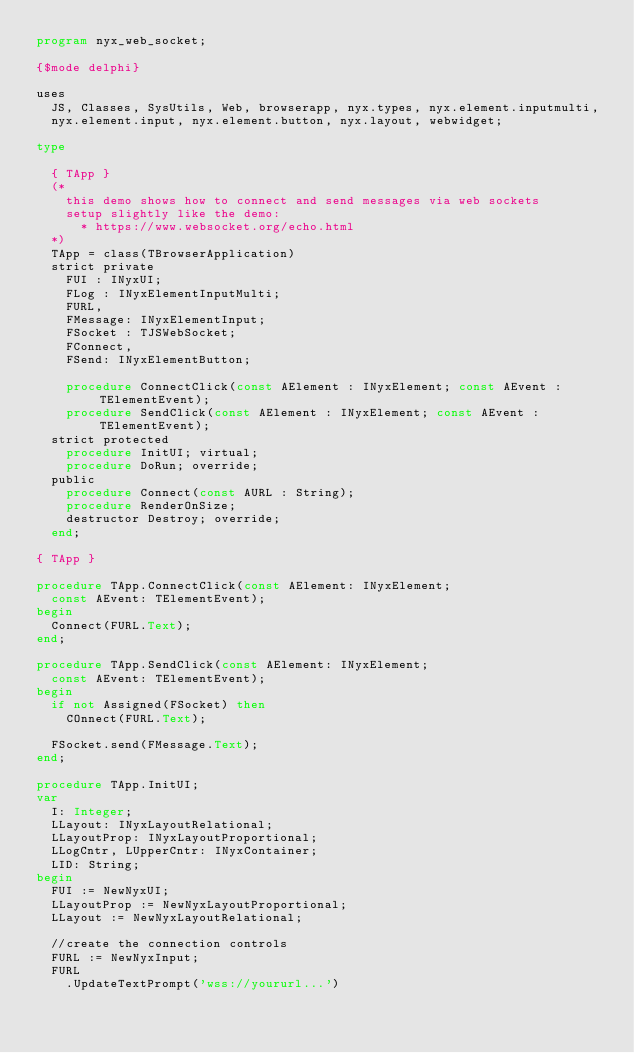<code> <loc_0><loc_0><loc_500><loc_500><_Pascal_>program nyx_web_socket;

{$mode delphi}

uses
  JS, Classes, SysUtils, Web, browserapp, nyx.types, nyx.element.inputmulti,
  nyx.element.input, nyx.element.button, nyx.layout, webwidget;

type

  { TApp }
  (*
    this demo shows how to connect and send messages via web sockets
    setup slightly like the demo:
      * https://www.websocket.org/echo.html
  *)
  TApp = class(TBrowserApplication)
  strict private
    FUI : INyxUI;
    FLog : INyxElementInputMulti;
    FURL,
    FMessage: INyxElementInput;
    FSocket : TJSWebSocket;
    FConnect,
    FSend: INyxElementButton;

    procedure ConnectClick(const AElement : INyxElement; const AEvent : TElementEvent);
    procedure SendClick(const AElement : INyxElement; const AEvent : TElementEvent);
  strict protected
    procedure InitUI; virtual;
    procedure DoRun; override;
  public
    procedure Connect(const AURL : String);
    procedure RenderOnSize;
    destructor Destroy; override;
  end;

{ TApp }

procedure TApp.ConnectClick(const AElement: INyxElement;
  const AEvent: TElementEvent);
begin
  Connect(FURL.Text);
end;

procedure TApp.SendClick(const AElement: INyxElement;
  const AEvent: TElementEvent);
begin
  if not Assigned(FSocket) then
    COnnect(FURL.Text);

  FSocket.send(FMessage.Text);
end;

procedure TApp.InitUI;
var
  I: Integer;
  LLayout: INyxLayoutRelational;
  LLayoutProp: INyxLayoutProportional;
  LLogCntr, LUpperCntr: INyxContainer;
  LID: String;
begin
  FUI := NewNyxUI;
  LLayoutProp := NewNyxLayoutProportional;
  LLayout := NewNyxLayoutRelational;

  //create the connection controls
  FURL := NewNyxInput;
  FURL
    .UpdateTextPrompt('wss://yoururl...')</code> 